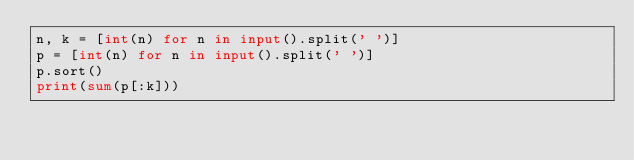<code> <loc_0><loc_0><loc_500><loc_500><_Python_>n, k = [int(n) for n in input().split(' ')]
p = [int(n) for n in input().split(' ')]
p.sort()
print(sum(p[:k]))
</code> 